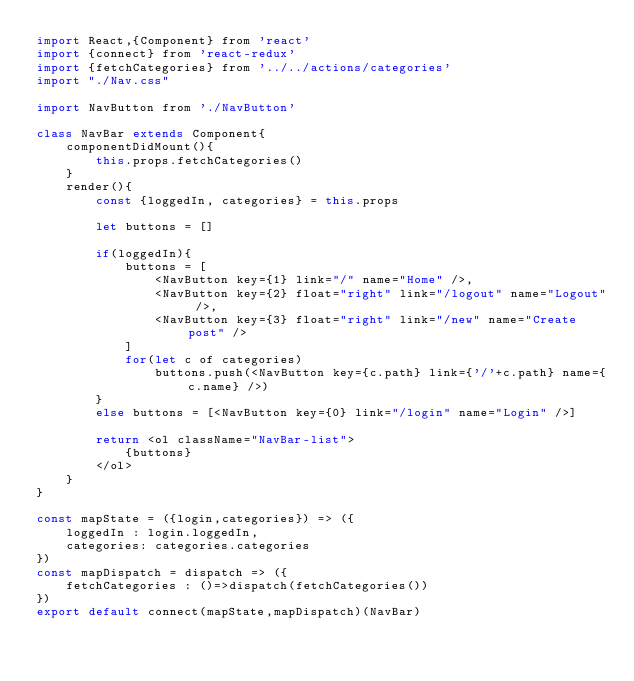Convert code to text. <code><loc_0><loc_0><loc_500><loc_500><_JavaScript_>import React,{Component} from 'react'
import {connect} from 'react-redux'
import {fetchCategories} from '../../actions/categories'
import "./Nav.css"

import NavButton from './NavButton'

class NavBar extends Component{
	componentDidMount(){
		this.props.fetchCategories()
	}
	render(){
		const {loggedIn, categories} = this.props
		
		let buttons = []

		if(loggedIn){
			buttons = [
				<NavButton key={1} link="/" name="Home" />,
				<NavButton key={2} float="right" link="/logout" name="Logout" />,
				<NavButton key={3} float="right" link="/new" name="Create post" />
			]
			for(let c of categories)
				buttons.push(<NavButton key={c.path} link={'/'+c.path} name={c.name} />)
		}
		else buttons = [<NavButton key={0} link="/login" name="Login" />]

		return <ol className="NavBar-list">
			{buttons}
		</ol>
	}
}

const mapState = ({login,categories}) => ({ 
	loggedIn : login.loggedIn,
	categories: categories.categories
})
const mapDispatch = dispatch => ({
	fetchCategories : ()=>dispatch(fetchCategories())
})
export default connect(mapState,mapDispatch)(NavBar)
</code> 